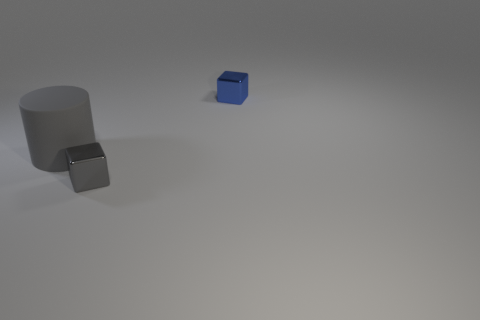Add 1 metal blocks. How many objects exist? 4 Subtract all blocks. How many objects are left? 1 Add 3 matte things. How many matte things are left? 4 Add 3 gray metallic blocks. How many gray metallic blocks exist? 4 Subtract 0 brown blocks. How many objects are left? 3 Subtract all big green rubber balls. Subtract all matte objects. How many objects are left? 2 